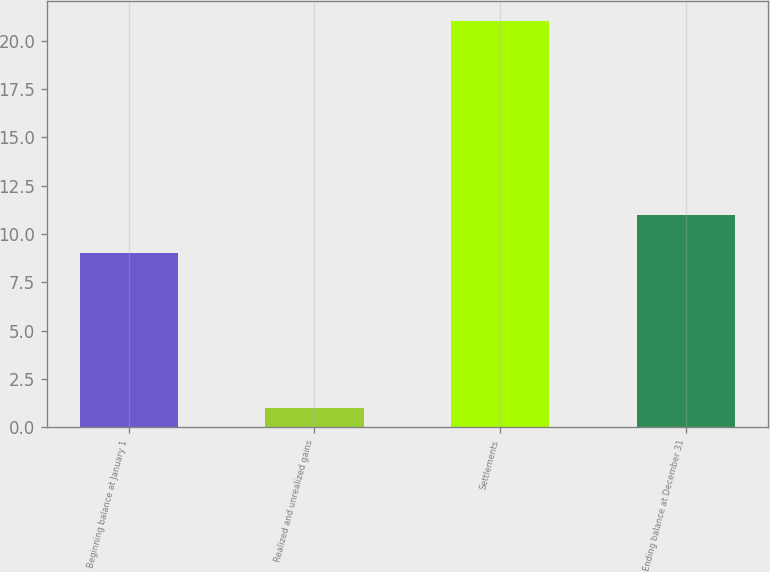<chart> <loc_0><loc_0><loc_500><loc_500><bar_chart><fcel>Beginning balance at January 1<fcel>Realized and unrealized gains<fcel>Settlements<fcel>Ending balance at December 31<nl><fcel>9<fcel>1<fcel>21<fcel>11<nl></chart> 